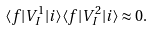Convert formula to latex. <formula><loc_0><loc_0><loc_500><loc_500>\langle f | V _ { I } ^ { 1 } | i \rangle \langle f | V _ { I } ^ { 2 } | i \rangle \approx 0 .</formula> 